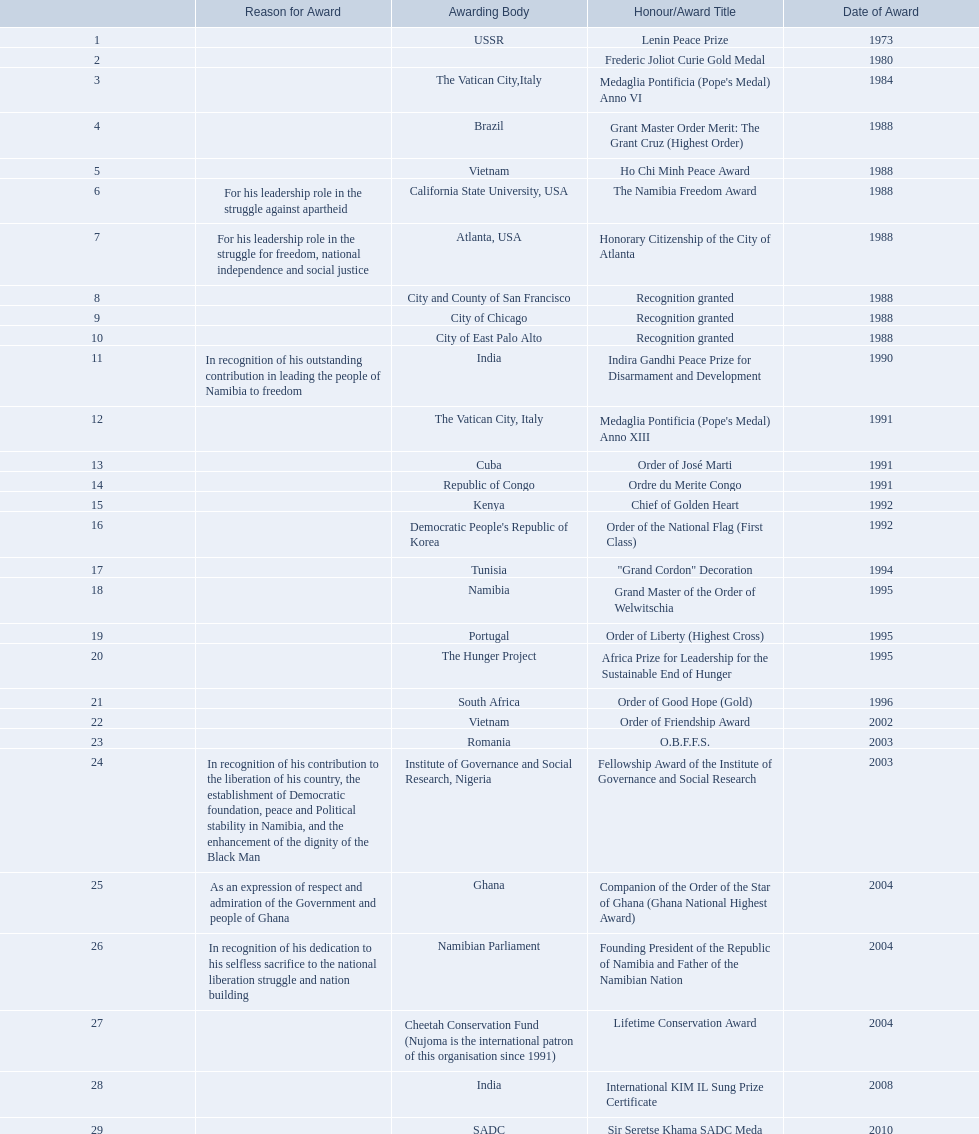What awards has sam nujoma been awarded? Lenin Peace Prize, Frederic Joliot Curie Gold Medal, Medaglia Pontificia (Pope's Medal) Anno VI, Grant Master Order Merit: The Grant Cruz (Highest Order), Ho Chi Minh Peace Award, The Namibia Freedom Award, Honorary Citizenship of the City of Atlanta, Recognition granted, Recognition granted, Recognition granted, Indira Gandhi Peace Prize for Disarmament and Development, Medaglia Pontificia (Pope's Medal) Anno XIII, Order of José Marti, Ordre du Merite Congo, Chief of Golden Heart, Order of the National Flag (First Class), "Grand Cordon" Decoration, Grand Master of the Order of Welwitschia, Order of Liberty (Highest Cross), Africa Prize for Leadership for the Sustainable End of Hunger, Order of Good Hope (Gold), Order of Friendship Award, O.B.F.F.S., Fellowship Award of the Institute of Governance and Social Research, Companion of the Order of the Star of Ghana (Ghana National Highest Award), Founding President of the Republic of Namibia and Father of the Namibian Nation, Lifetime Conservation Award, International KIM IL Sung Prize Certificate, Sir Seretse Khama SADC Meda. By which awarding body did sam nujoma receive the o.b.f.f.s award? Romania. 